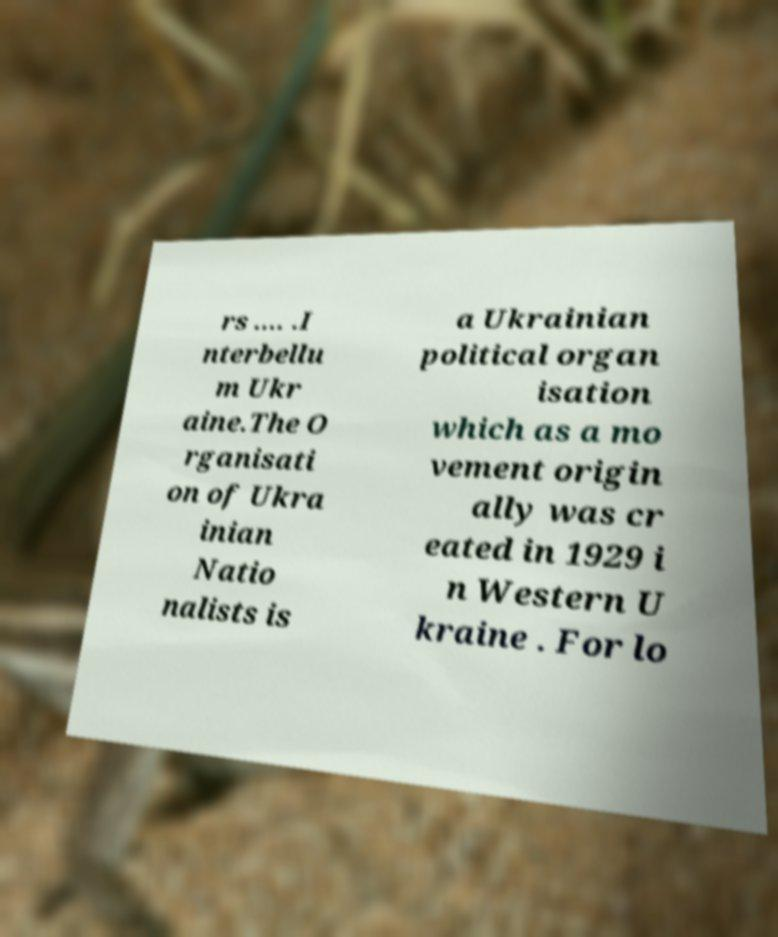Please read and relay the text visible in this image. What does it say? rs .... .I nterbellu m Ukr aine.The O rganisati on of Ukra inian Natio nalists is a Ukrainian political organ isation which as a mo vement origin ally was cr eated in 1929 i n Western U kraine . For lo 